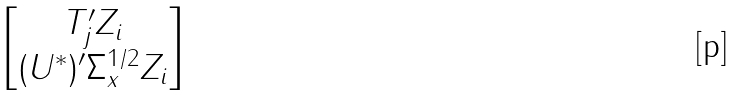Convert formula to latex. <formula><loc_0><loc_0><loc_500><loc_500>\begin{bmatrix} T _ { j } ^ { \prime } Z _ { i } \\ ( U ^ { * } ) ^ { \prime } \Sigma _ { x } ^ { 1 / 2 } Z _ { i } \end{bmatrix}</formula> 